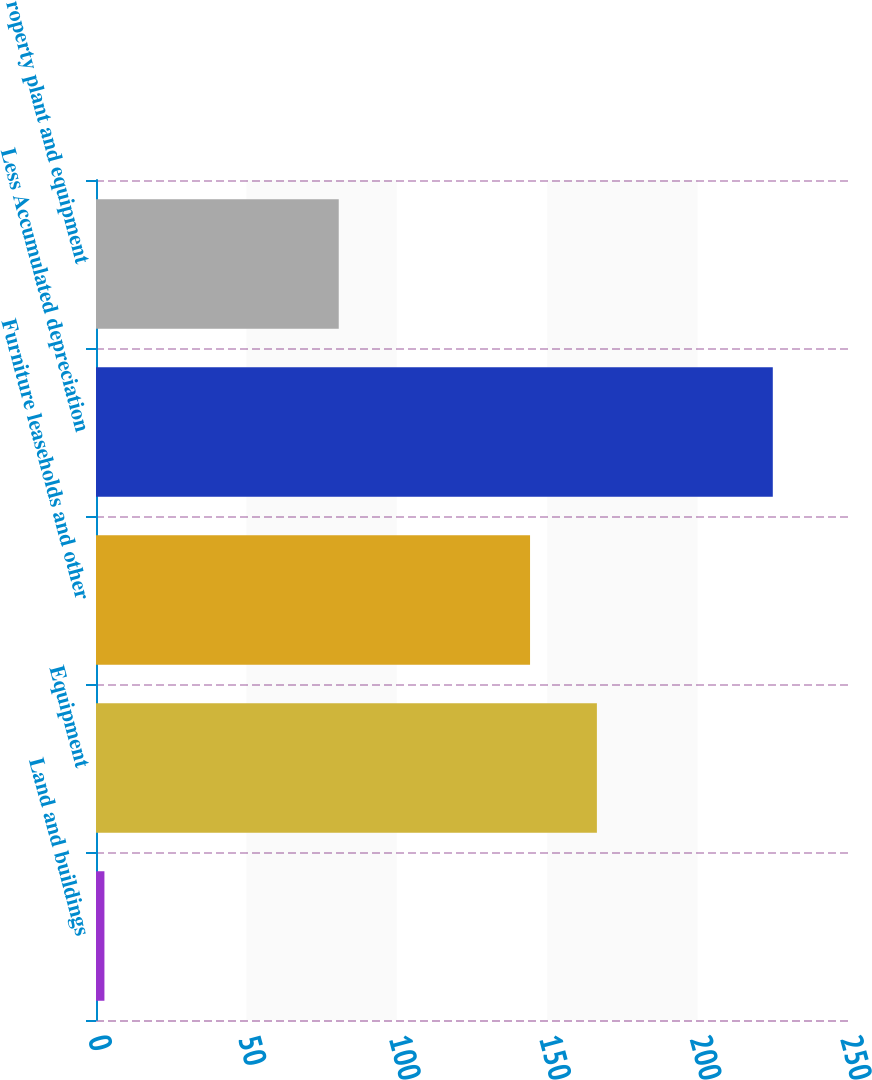<chart> <loc_0><loc_0><loc_500><loc_500><bar_chart><fcel>Land and buildings<fcel>Equipment<fcel>Furniture leaseholds and other<fcel>Less Accumulated depreciation<fcel>Property plant and equipment<nl><fcel>2.8<fcel>166.52<fcel>144.3<fcel>225<fcel>80.7<nl></chart> 